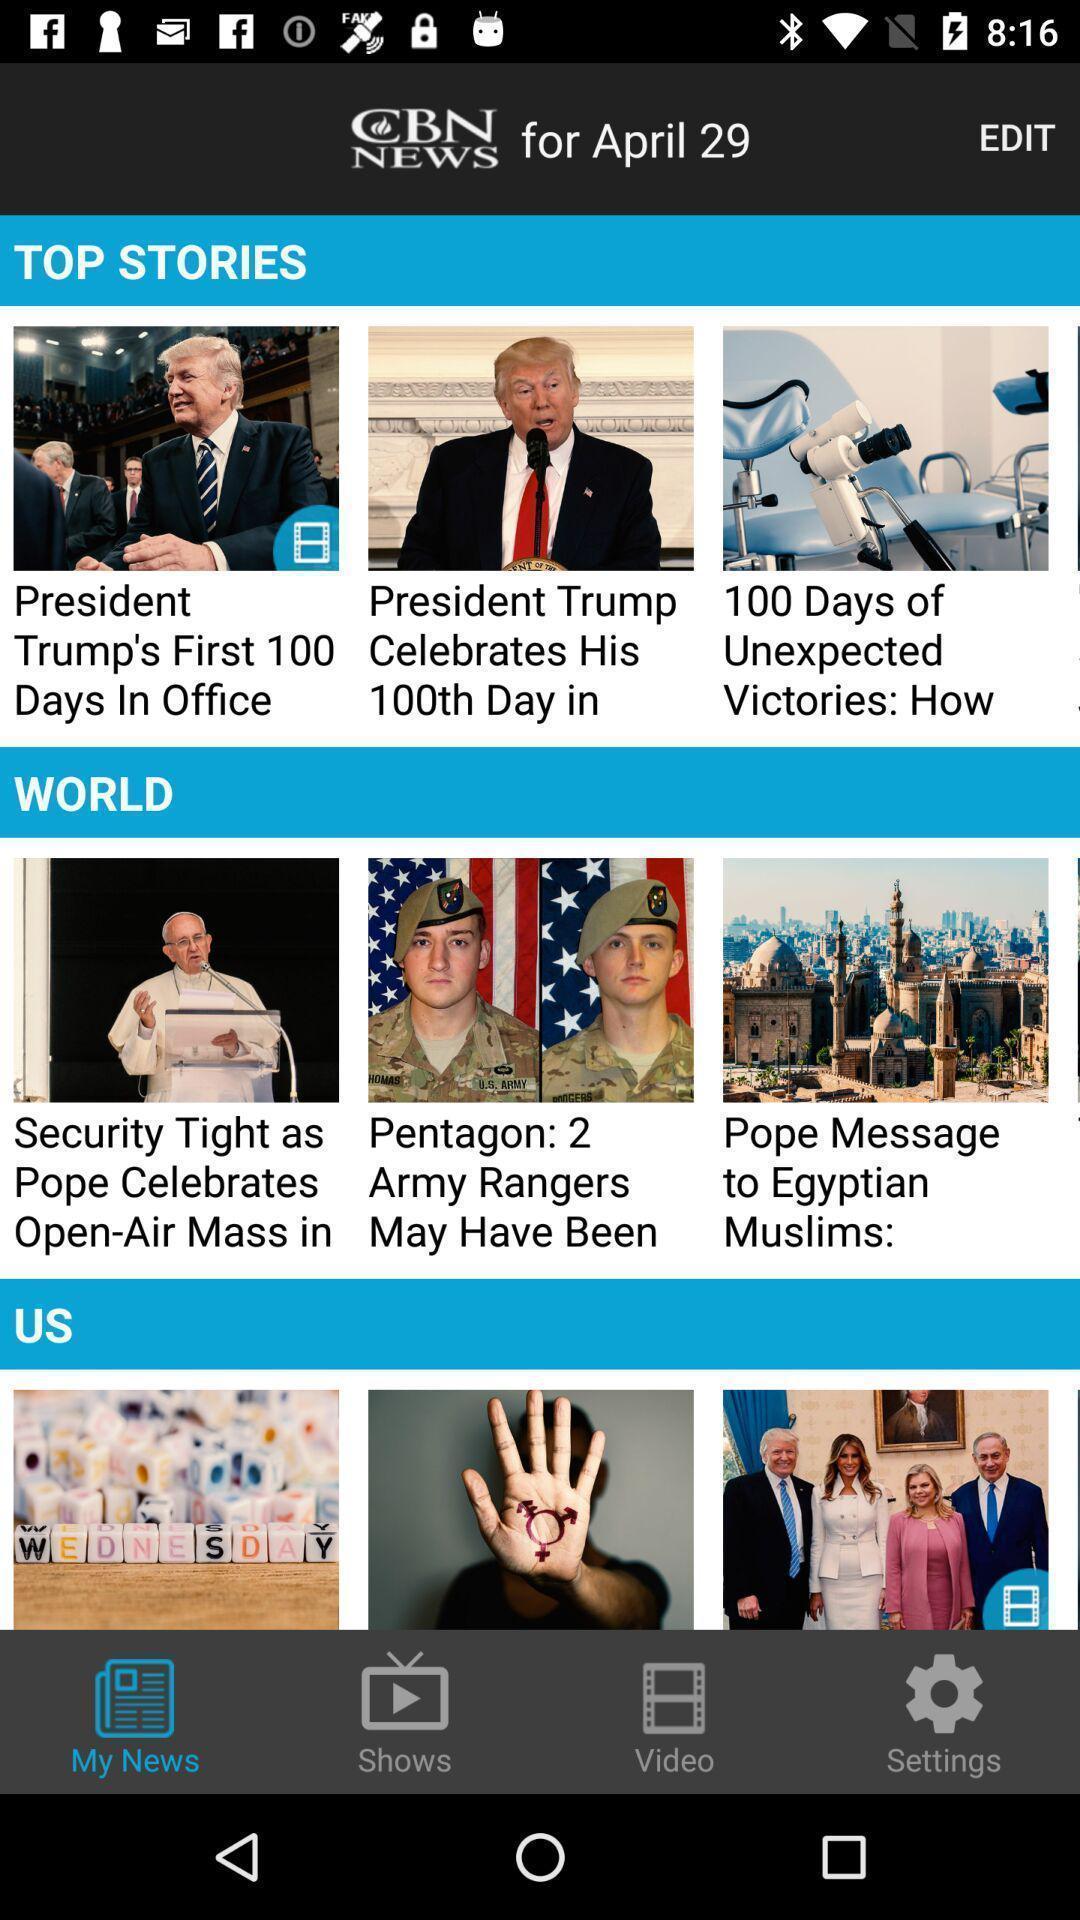Provide a textual representation of this image. Screen showing top stories. 